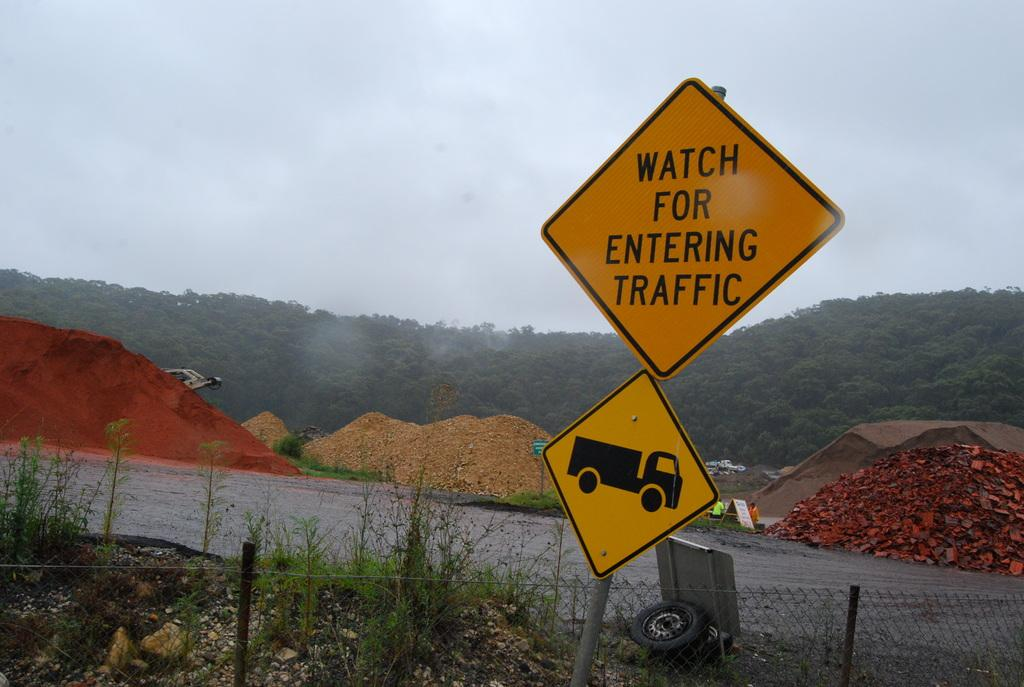<image>
Create a compact narrative representing the image presented. A yellow sign warns to watch for entering for traffic. 